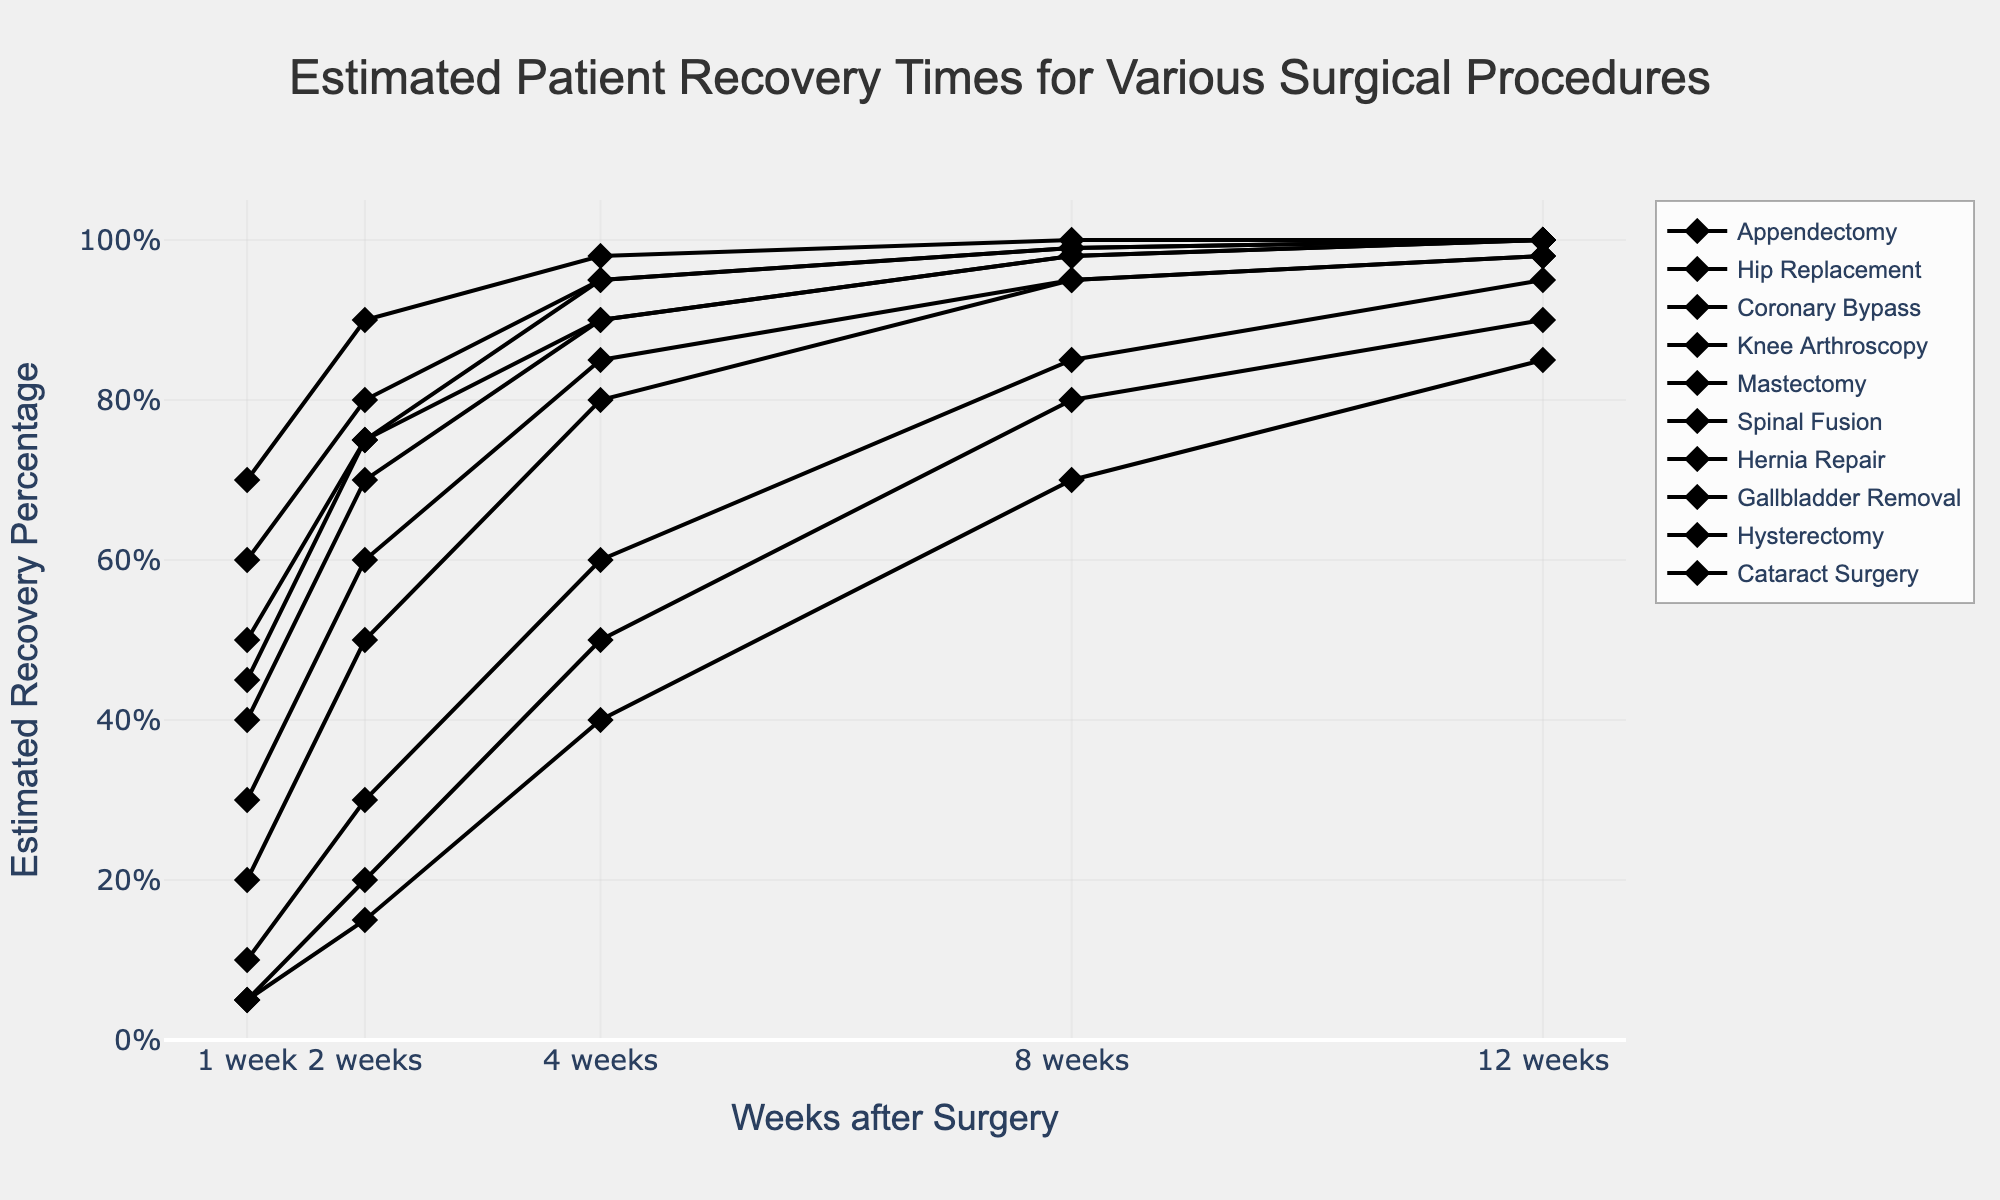What's the percentage recovery rate at 1 week for Cataract Surgery? The percentage recovery rate at 1 week for Cataract Surgery can be read directly from the plotted line or data table.
Answer: 70% What's the title of the chart? The title is displayed at the top of the chart. It summarizes the chart's purpose, which is to show recovery times.
Answer: Estimated Patient Recovery Times for Various Surgical Procedures Which surgical procedure has the lowest recovery rate at 4 weeks? The recovery rates at 4 weeks for all procedures can be read from the y-axis and compared. Coronary Bypass shows the lowest percentage.
Answer: Coronary Bypass How does the recovery rate for Hip Replacement compare at 8 weeks and 12 weeks? Read the recovery rates at 8 weeks and 12 weeks for Hip Replacement and compare them. At 8 weeks, it's 85%, and at 12 weeks, it's 95%.
Answer: It increases by 10% What is the difference in the estimated recovery percentage at 2 weeks between Hernia Repair and Hysterectomy? Read the recovery percentage at 2 weeks for both procedures and subtract the smaller value from the larger. Hernia Repair is 75%, and Hysterectomy is 50%.
Answer: 25% Which procedure reaches a 100% recovery rate the earliest? Find which procedure's line reaches the highest point (100%) the quickest when moving from left to right across the x-axis (weeks). Cataract Surgery reaches 100% the earliest.
Answer: Cataract Surgery How many surgical procedures have an estimated recovery percentage of at least 95% at 8 weeks? Count the procedures for which the recovery percentage crosses the 95% mark at the 8-week point on the x-axis. They are Appendectomy, Knee Arthroscopy, Hernia Repair, and Gallbladder Removal.
Answer: Four procedures Which procedures reach an estimated 100% recovery rate at both 8 weeks and 12 weeks? Look for procedures whose lines touch the 100% mark at both 8 weeks and 12 weeks. Appendectomy, Knee Arthroscopy, Hernia Repair, and Gallbladder Removal all meet this criterion.
Answer: Appendectomy, Knee Arthroscopy, Hernia Repair, Gallbladder Removal What can you infer about recovery trajectories for Spinal Fusion compared to Knee Arthroscopy? Analyze the slopes of the lines representing Spinal Fusion and Knee Arthroscopy over the weeks. Spinal Fusion starts low and rises steadily but remains lower than Knee Arthroscopy at all points measured. Knee Arthroscopy has quicker recovery gains and reaches 100%.
Answer: Spinal Fusion has slower recovery than Knee Arthroscopy What percentage of recovery is achieved at 1 week for Hip Replacement compared to Mastectomy? Read the recovery percentages for Hip Replacement and Mastectomy at the 1-week mark. Hip Replacement is at 10%, and Mastectomy is at 30%.
Answer: Mastectomy is 20% higher 